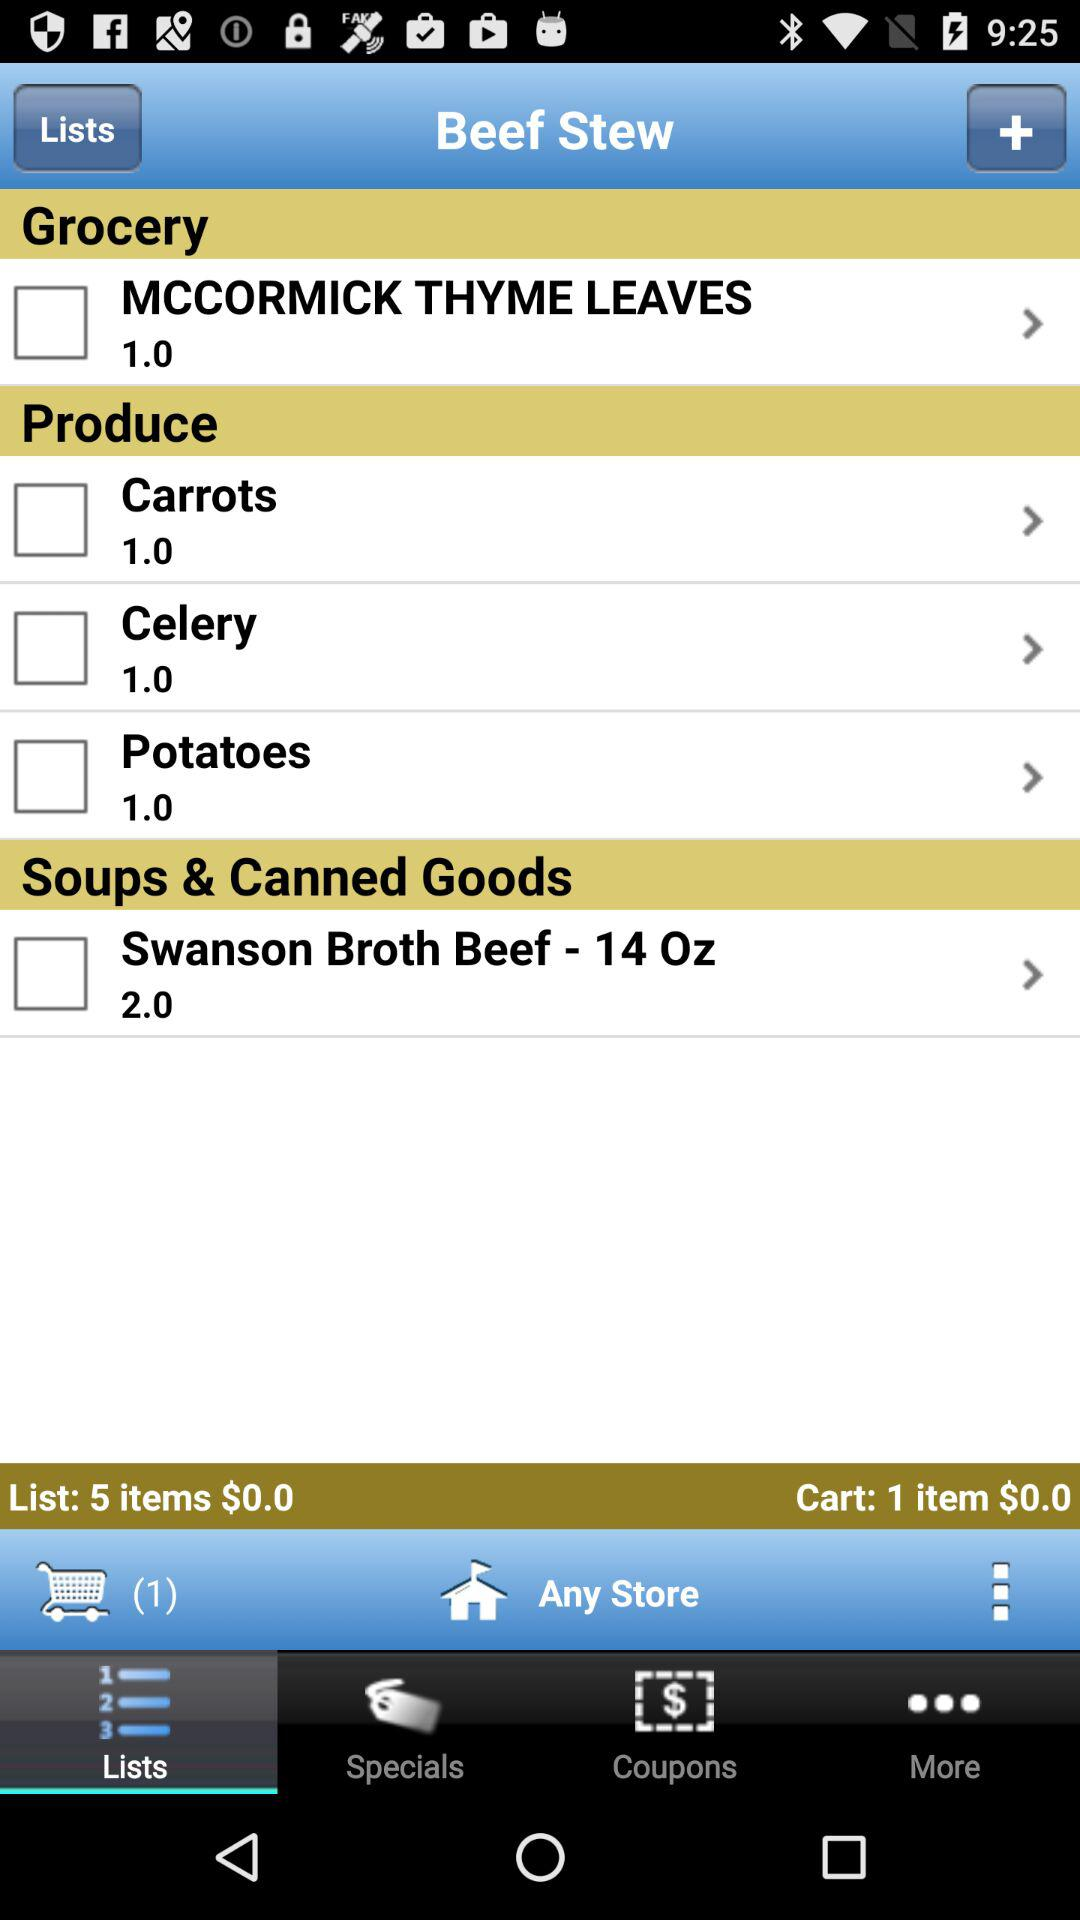How many items are in the cart?
Answer the question using a single word or phrase. 1 